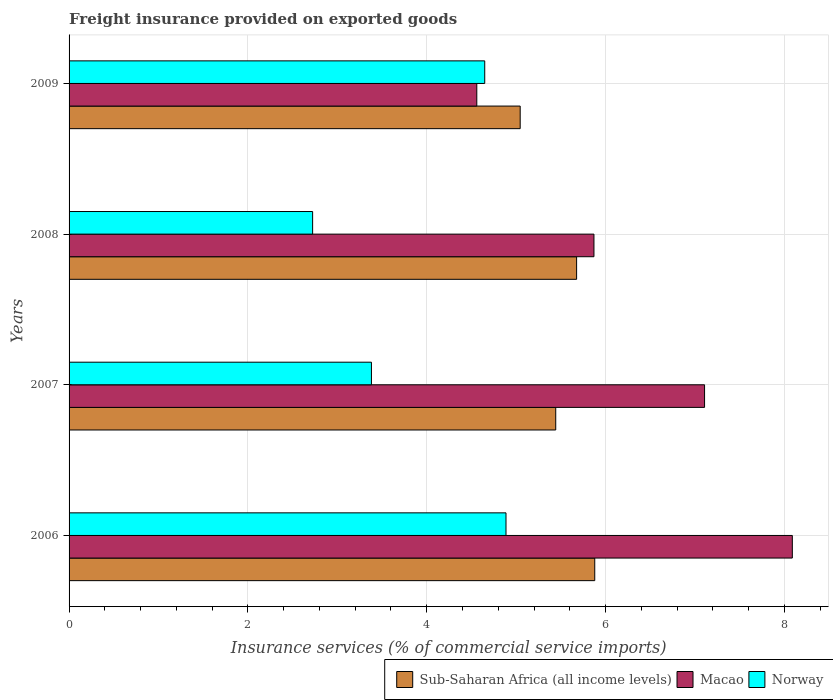How many groups of bars are there?
Provide a succinct answer. 4. Are the number of bars on each tick of the Y-axis equal?
Your response must be concise. Yes. What is the label of the 2nd group of bars from the top?
Your response must be concise. 2008. What is the freight insurance provided on exported goods in Norway in 2009?
Provide a short and direct response. 4.65. Across all years, what is the maximum freight insurance provided on exported goods in Norway?
Provide a succinct answer. 4.89. Across all years, what is the minimum freight insurance provided on exported goods in Macao?
Your response must be concise. 4.56. What is the total freight insurance provided on exported goods in Sub-Saharan Africa (all income levels) in the graph?
Offer a very short reply. 22.04. What is the difference between the freight insurance provided on exported goods in Norway in 2006 and that in 2008?
Offer a terse response. 2.16. What is the difference between the freight insurance provided on exported goods in Macao in 2006 and the freight insurance provided on exported goods in Sub-Saharan Africa (all income levels) in 2009?
Your answer should be very brief. 3.04. What is the average freight insurance provided on exported goods in Sub-Saharan Africa (all income levels) per year?
Offer a very short reply. 5.51. In the year 2009, what is the difference between the freight insurance provided on exported goods in Macao and freight insurance provided on exported goods in Norway?
Offer a very short reply. -0.09. What is the ratio of the freight insurance provided on exported goods in Sub-Saharan Africa (all income levels) in 2006 to that in 2009?
Provide a succinct answer. 1.17. What is the difference between the highest and the second highest freight insurance provided on exported goods in Sub-Saharan Africa (all income levels)?
Offer a terse response. 0.2. What is the difference between the highest and the lowest freight insurance provided on exported goods in Macao?
Ensure brevity in your answer.  3.53. In how many years, is the freight insurance provided on exported goods in Macao greater than the average freight insurance provided on exported goods in Macao taken over all years?
Offer a very short reply. 2. What does the 2nd bar from the top in 2006 represents?
Offer a very short reply. Macao. What does the 3rd bar from the bottom in 2008 represents?
Keep it short and to the point. Norway. Is it the case that in every year, the sum of the freight insurance provided on exported goods in Norway and freight insurance provided on exported goods in Macao is greater than the freight insurance provided on exported goods in Sub-Saharan Africa (all income levels)?
Provide a succinct answer. Yes. Are all the bars in the graph horizontal?
Your answer should be compact. Yes. How many years are there in the graph?
Give a very brief answer. 4. Does the graph contain grids?
Offer a very short reply. Yes. How many legend labels are there?
Ensure brevity in your answer.  3. How are the legend labels stacked?
Provide a succinct answer. Horizontal. What is the title of the graph?
Your answer should be compact. Freight insurance provided on exported goods. What is the label or title of the X-axis?
Keep it short and to the point. Insurance services (% of commercial service imports). What is the Insurance services (% of commercial service imports) of Sub-Saharan Africa (all income levels) in 2006?
Your answer should be compact. 5.88. What is the Insurance services (% of commercial service imports) in Macao in 2006?
Your response must be concise. 8.09. What is the Insurance services (% of commercial service imports) in Norway in 2006?
Provide a succinct answer. 4.89. What is the Insurance services (% of commercial service imports) in Sub-Saharan Africa (all income levels) in 2007?
Make the answer very short. 5.44. What is the Insurance services (% of commercial service imports) of Macao in 2007?
Ensure brevity in your answer.  7.11. What is the Insurance services (% of commercial service imports) of Norway in 2007?
Provide a short and direct response. 3.38. What is the Insurance services (% of commercial service imports) in Sub-Saharan Africa (all income levels) in 2008?
Your answer should be compact. 5.68. What is the Insurance services (% of commercial service imports) of Macao in 2008?
Give a very brief answer. 5.87. What is the Insurance services (% of commercial service imports) in Norway in 2008?
Keep it short and to the point. 2.72. What is the Insurance services (% of commercial service imports) in Sub-Saharan Africa (all income levels) in 2009?
Ensure brevity in your answer.  5.05. What is the Insurance services (% of commercial service imports) of Macao in 2009?
Your answer should be compact. 4.56. What is the Insurance services (% of commercial service imports) in Norway in 2009?
Provide a short and direct response. 4.65. Across all years, what is the maximum Insurance services (% of commercial service imports) of Sub-Saharan Africa (all income levels)?
Provide a short and direct response. 5.88. Across all years, what is the maximum Insurance services (% of commercial service imports) in Macao?
Offer a terse response. 8.09. Across all years, what is the maximum Insurance services (% of commercial service imports) in Norway?
Ensure brevity in your answer.  4.89. Across all years, what is the minimum Insurance services (% of commercial service imports) in Sub-Saharan Africa (all income levels)?
Offer a terse response. 5.05. Across all years, what is the minimum Insurance services (% of commercial service imports) of Macao?
Give a very brief answer. 4.56. Across all years, what is the minimum Insurance services (% of commercial service imports) in Norway?
Make the answer very short. 2.72. What is the total Insurance services (% of commercial service imports) in Sub-Saharan Africa (all income levels) in the graph?
Make the answer very short. 22.04. What is the total Insurance services (% of commercial service imports) of Macao in the graph?
Offer a terse response. 25.63. What is the total Insurance services (% of commercial service imports) of Norway in the graph?
Provide a short and direct response. 15.64. What is the difference between the Insurance services (% of commercial service imports) of Sub-Saharan Africa (all income levels) in 2006 and that in 2007?
Keep it short and to the point. 0.44. What is the difference between the Insurance services (% of commercial service imports) in Macao in 2006 and that in 2007?
Your answer should be compact. 0.98. What is the difference between the Insurance services (% of commercial service imports) of Norway in 2006 and that in 2007?
Your answer should be very brief. 1.5. What is the difference between the Insurance services (% of commercial service imports) in Sub-Saharan Africa (all income levels) in 2006 and that in 2008?
Keep it short and to the point. 0.2. What is the difference between the Insurance services (% of commercial service imports) in Macao in 2006 and that in 2008?
Give a very brief answer. 2.22. What is the difference between the Insurance services (% of commercial service imports) of Norway in 2006 and that in 2008?
Offer a very short reply. 2.16. What is the difference between the Insurance services (% of commercial service imports) in Sub-Saharan Africa (all income levels) in 2006 and that in 2009?
Ensure brevity in your answer.  0.83. What is the difference between the Insurance services (% of commercial service imports) in Macao in 2006 and that in 2009?
Provide a succinct answer. 3.53. What is the difference between the Insurance services (% of commercial service imports) of Norway in 2006 and that in 2009?
Make the answer very short. 0.24. What is the difference between the Insurance services (% of commercial service imports) in Sub-Saharan Africa (all income levels) in 2007 and that in 2008?
Offer a terse response. -0.23. What is the difference between the Insurance services (% of commercial service imports) of Macao in 2007 and that in 2008?
Make the answer very short. 1.24. What is the difference between the Insurance services (% of commercial service imports) of Norway in 2007 and that in 2008?
Give a very brief answer. 0.66. What is the difference between the Insurance services (% of commercial service imports) of Sub-Saharan Africa (all income levels) in 2007 and that in 2009?
Your response must be concise. 0.4. What is the difference between the Insurance services (% of commercial service imports) in Macao in 2007 and that in 2009?
Offer a very short reply. 2.55. What is the difference between the Insurance services (% of commercial service imports) of Norway in 2007 and that in 2009?
Provide a short and direct response. -1.27. What is the difference between the Insurance services (% of commercial service imports) of Sub-Saharan Africa (all income levels) in 2008 and that in 2009?
Make the answer very short. 0.63. What is the difference between the Insurance services (% of commercial service imports) in Macao in 2008 and that in 2009?
Keep it short and to the point. 1.31. What is the difference between the Insurance services (% of commercial service imports) in Norway in 2008 and that in 2009?
Make the answer very short. -1.93. What is the difference between the Insurance services (% of commercial service imports) of Sub-Saharan Africa (all income levels) in 2006 and the Insurance services (% of commercial service imports) of Macao in 2007?
Offer a very short reply. -1.23. What is the difference between the Insurance services (% of commercial service imports) in Sub-Saharan Africa (all income levels) in 2006 and the Insurance services (% of commercial service imports) in Norway in 2007?
Give a very brief answer. 2.5. What is the difference between the Insurance services (% of commercial service imports) of Macao in 2006 and the Insurance services (% of commercial service imports) of Norway in 2007?
Provide a succinct answer. 4.71. What is the difference between the Insurance services (% of commercial service imports) of Sub-Saharan Africa (all income levels) in 2006 and the Insurance services (% of commercial service imports) of Macao in 2008?
Give a very brief answer. 0.01. What is the difference between the Insurance services (% of commercial service imports) of Sub-Saharan Africa (all income levels) in 2006 and the Insurance services (% of commercial service imports) of Norway in 2008?
Offer a very short reply. 3.16. What is the difference between the Insurance services (% of commercial service imports) in Macao in 2006 and the Insurance services (% of commercial service imports) in Norway in 2008?
Make the answer very short. 5.37. What is the difference between the Insurance services (% of commercial service imports) in Sub-Saharan Africa (all income levels) in 2006 and the Insurance services (% of commercial service imports) in Macao in 2009?
Offer a very short reply. 1.32. What is the difference between the Insurance services (% of commercial service imports) of Sub-Saharan Africa (all income levels) in 2006 and the Insurance services (% of commercial service imports) of Norway in 2009?
Your answer should be very brief. 1.23. What is the difference between the Insurance services (% of commercial service imports) in Macao in 2006 and the Insurance services (% of commercial service imports) in Norway in 2009?
Make the answer very short. 3.44. What is the difference between the Insurance services (% of commercial service imports) in Sub-Saharan Africa (all income levels) in 2007 and the Insurance services (% of commercial service imports) in Macao in 2008?
Provide a succinct answer. -0.43. What is the difference between the Insurance services (% of commercial service imports) of Sub-Saharan Africa (all income levels) in 2007 and the Insurance services (% of commercial service imports) of Norway in 2008?
Your answer should be compact. 2.72. What is the difference between the Insurance services (% of commercial service imports) in Macao in 2007 and the Insurance services (% of commercial service imports) in Norway in 2008?
Give a very brief answer. 4.38. What is the difference between the Insurance services (% of commercial service imports) of Sub-Saharan Africa (all income levels) in 2007 and the Insurance services (% of commercial service imports) of Macao in 2009?
Provide a succinct answer. 0.88. What is the difference between the Insurance services (% of commercial service imports) in Sub-Saharan Africa (all income levels) in 2007 and the Insurance services (% of commercial service imports) in Norway in 2009?
Your answer should be compact. 0.79. What is the difference between the Insurance services (% of commercial service imports) of Macao in 2007 and the Insurance services (% of commercial service imports) of Norway in 2009?
Make the answer very short. 2.46. What is the difference between the Insurance services (% of commercial service imports) in Sub-Saharan Africa (all income levels) in 2008 and the Insurance services (% of commercial service imports) in Macao in 2009?
Give a very brief answer. 1.12. What is the difference between the Insurance services (% of commercial service imports) in Sub-Saharan Africa (all income levels) in 2008 and the Insurance services (% of commercial service imports) in Norway in 2009?
Your answer should be very brief. 1.03. What is the difference between the Insurance services (% of commercial service imports) of Macao in 2008 and the Insurance services (% of commercial service imports) of Norway in 2009?
Your answer should be compact. 1.22. What is the average Insurance services (% of commercial service imports) of Sub-Saharan Africa (all income levels) per year?
Give a very brief answer. 5.51. What is the average Insurance services (% of commercial service imports) in Macao per year?
Your answer should be very brief. 6.41. What is the average Insurance services (% of commercial service imports) in Norway per year?
Provide a succinct answer. 3.91. In the year 2006, what is the difference between the Insurance services (% of commercial service imports) in Sub-Saharan Africa (all income levels) and Insurance services (% of commercial service imports) in Macao?
Ensure brevity in your answer.  -2.21. In the year 2006, what is the difference between the Insurance services (% of commercial service imports) of Macao and Insurance services (% of commercial service imports) of Norway?
Provide a succinct answer. 3.2. In the year 2007, what is the difference between the Insurance services (% of commercial service imports) in Sub-Saharan Africa (all income levels) and Insurance services (% of commercial service imports) in Macao?
Your answer should be compact. -1.66. In the year 2007, what is the difference between the Insurance services (% of commercial service imports) in Sub-Saharan Africa (all income levels) and Insurance services (% of commercial service imports) in Norway?
Your response must be concise. 2.06. In the year 2007, what is the difference between the Insurance services (% of commercial service imports) in Macao and Insurance services (% of commercial service imports) in Norway?
Your answer should be compact. 3.73. In the year 2008, what is the difference between the Insurance services (% of commercial service imports) of Sub-Saharan Africa (all income levels) and Insurance services (% of commercial service imports) of Macao?
Your answer should be compact. -0.19. In the year 2008, what is the difference between the Insurance services (% of commercial service imports) in Sub-Saharan Africa (all income levels) and Insurance services (% of commercial service imports) in Norway?
Offer a very short reply. 2.95. In the year 2008, what is the difference between the Insurance services (% of commercial service imports) of Macao and Insurance services (% of commercial service imports) of Norway?
Your answer should be compact. 3.15. In the year 2009, what is the difference between the Insurance services (% of commercial service imports) in Sub-Saharan Africa (all income levels) and Insurance services (% of commercial service imports) in Macao?
Provide a succinct answer. 0.49. In the year 2009, what is the difference between the Insurance services (% of commercial service imports) in Sub-Saharan Africa (all income levels) and Insurance services (% of commercial service imports) in Norway?
Your answer should be compact. 0.4. In the year 2009, what is the difference between the Insurance services (% of commercial service imports) in Macao and Insurance services (% of commercial service imports) in Norway?
Offer a very short reply. -0.09. What is the ratio of the Insurance services (% of commercial service imports) of Sub-Saharan Africa (all income levels) in 2006 to that in 2007?
Your answer should be very brief. 1.08. What is the ratio of the Insurance services (% of commercial service imports) in Macao in 2006 to that in 2007?
Provide a short and direct response. 1.14. What is the ratio of the Insurance services (% of commercial service imports) in Norway in 2006 to that in 2007?
Make the answer very short. 1.45. What is the ratio of the Insurance services (% of commercial service imports) in Sub-Saharan Africa (all income levels) in 2006 to that in 2008?
Offer a terse response. 1.04. What is the ratio of the Insurance services (% of commercial service imports) of Macao in 2006 to that in 2008?
Offer a very short reply. 1.38. What is the ratio of the Insurance services (% of commercial service imports) in Norway in 2006 to that in 2008?
Provide a short and direct response. 1.79. What is the ratio of the Insurance services (% of commercial service imports) of Sub-Saharan Africa (all income levels) in 2006 to that in 2009?
Give a very brief answer. 1.17. What is the ratio of the Insurance services (% of commercial service imports) in Macao in 2006 to that in 2009?
Offer a terse response. 1.77. What is the ratio of the Insurance services (% of commercial service imports) of Norway in 2006 to that in 2009?
Provide a succinct answer. 1.05. What is the ratio of the Insurance services (% of commercial service imports) of Sub-Saharan Africa (all income levels) in 2007 to that in 2008?
Your response must be concise. 0.96. What is the ratio of the Insurance services (% of commercial service imports) in Macao in 2007 to that in 2008?
Your response must be concise. 1.21. What is the ratio of the Insurance services (% of commercial service imports) of Norway in 2007 to that in 2008?
Offer a very short reply. 1.24. What is the ratio of the Insurance services (% of commercial service imports) in Sub-Saharan Africa (all income levels) in 2007 to that in 2009?
Offer a terse response. 1.08. What is the ratio of the Insurance services (% of commercial service imports) of Macao in 2007 to that in 2009?
Your answer should be compact. 1.56. What is the ratio of the Insurance services (% of commercial service imports) in Norway in 2007 to that in 2009?
Ensure brevity in your answer.  0.73. What is the ratio of the Insurance services (% of commercial service imports) in Sub-Saharan Africa (all income levels) in 2008 to that in 2009?
Ensure brevity in your answer.  1.13. What is the ratio of the Insurance services (% of commercial service imports) in Macao in 2008 to that in 2009?
Your response must be concise. 1.29. What is the ratio of the Insurance services (% of commercial service imports) in Norway in 2008 to that in 2009?
Offer a very short reply. 0.59. What is the difference between the highest and the second highest Insurance services (% of commercial service imports) in Sub-Saharan Africa (all income levels)?
Provide a short and direct response. 0.2. What is the difference between the highest and the second highest Insurance services (% of commercial service imports) in Macao?
Offer a very short reply. 0.98. What is the difference between the highest and the second highest Insurance services (% of commercial service imports) in Norway?
Your response must be concise. 0.24. What is the difference between the highest and the lowest Insurance services (% of commercial service imports) of Sub-Saharan Africa (all income levels)?
Offer a very short reply. 0.83. What is the difference between the highest and the lowest Insurance services (% of commercial service imports) in Macao?
Offer a very short reply. 3.53. What is the difference between the highest and the lowest Insurance services (% of commercial service imports) of Norway?
Offer a very short reply. 2.16. 